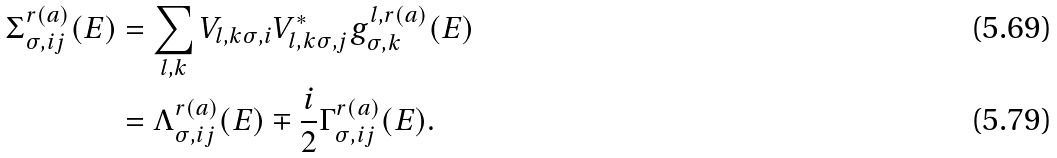Convert formula to latex. <formula><loc_0><loc_0><loc_500><loc_500>\Sigma ^ { r ( a ) } _ { \sigma , i j } ( E ) & = \sum _ { l , k } V _ { l , k \sigma , i } V _ { l , k \sigma , j } ^ { * } g ^ { l , r ( a ) } _ { \sigma , k } ( E ) \\ & = \Lambda ^ { r ( a ) } _ { \sigma , i j } ( E ) \mp \frac { i } { 2 } \Gamma ^ { r ( a ) } _ { \sigma , i j } ( E ) .</formula> 